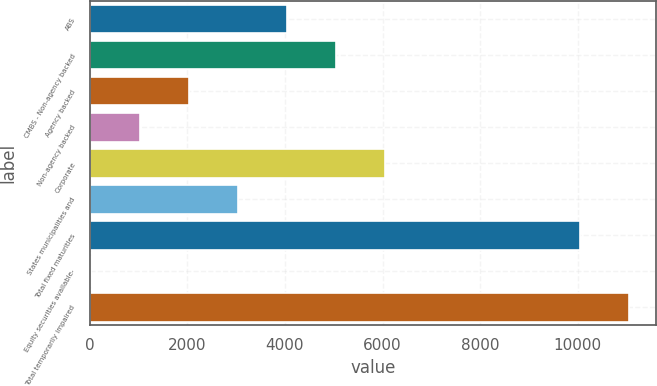<chart> <loc_0><loc_0><loc_500><loc_500><bar_chart><fcel>ABS<fcel>CMBS - Non-agency backed<fcel>Agency backed<fcel>Non-agency backed<fcel>Corporate<fcel>States municipalities and<fcel>Total fixed maturities<fcel>Equity securities available-<fcel>Total temporarily impaired<nl><fcel>4040.4<fcel>5045.5<fcel>2030.2<fcel>1025.1<fcel>6050.6<fcel>3035.3<fcel>10051<fcel>20<fcel>11056.1<nl></chart> 